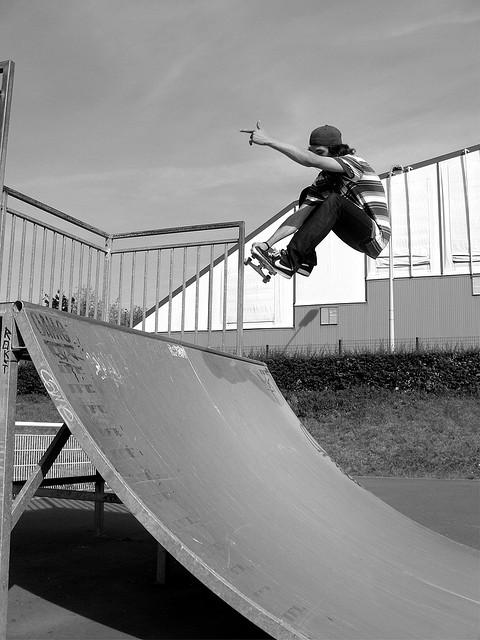Is the skateboarder doing a trick?
Short answer required. Yes. Is this picture in black and white?
Answer briefly. Yes. What makes this dangerous?
Short answer required. Height. Is the person airborne?
Be succinct. Yes. 